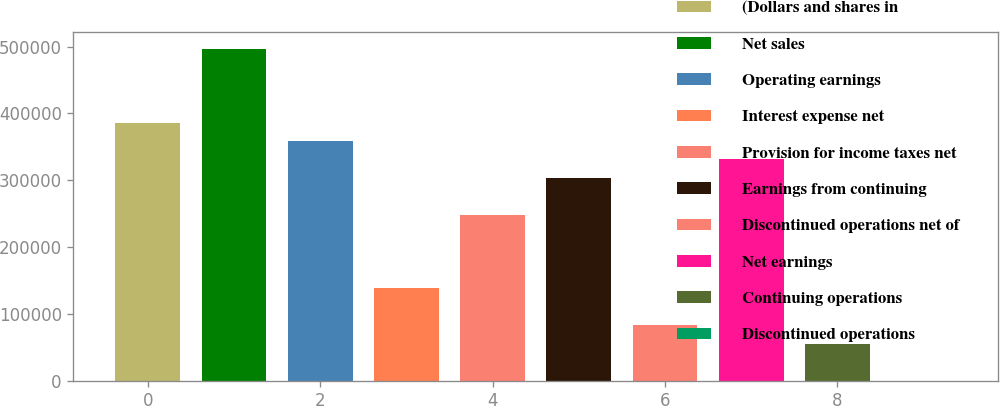Convert chart to OTSL. <chart><loc_0><loc_0><loc_500><loc_500><bar_chart><fcel>(Dollars and shares in<fcel>Net sales<fcel>Operating earnings<fcel>Interest expense net<fcel>Provision for income taxes net<fcel>Earnings from continuing<fcel>Discontinued operations net of<fcel>Net earnings<fcel>Continuing operations<fcel>Discontinued operations<nl><fcel>386400<fcel>496800<fcel>358800<fcel>138000<fcel>248400<fcel>303600<fcel>82800.1<fcel>331200<fcel>55200.1<fcel>0.13<nl></chart> 